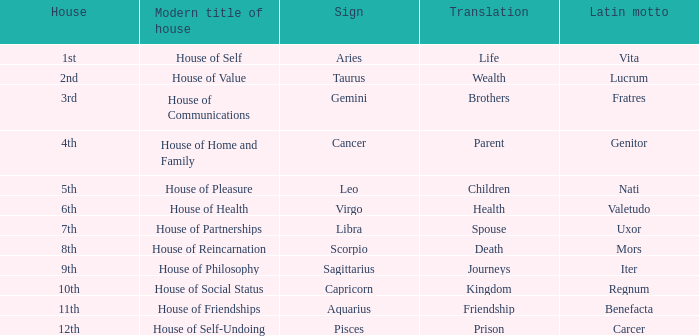Which astrological sign has the Latin motto of Vita? Aries. 